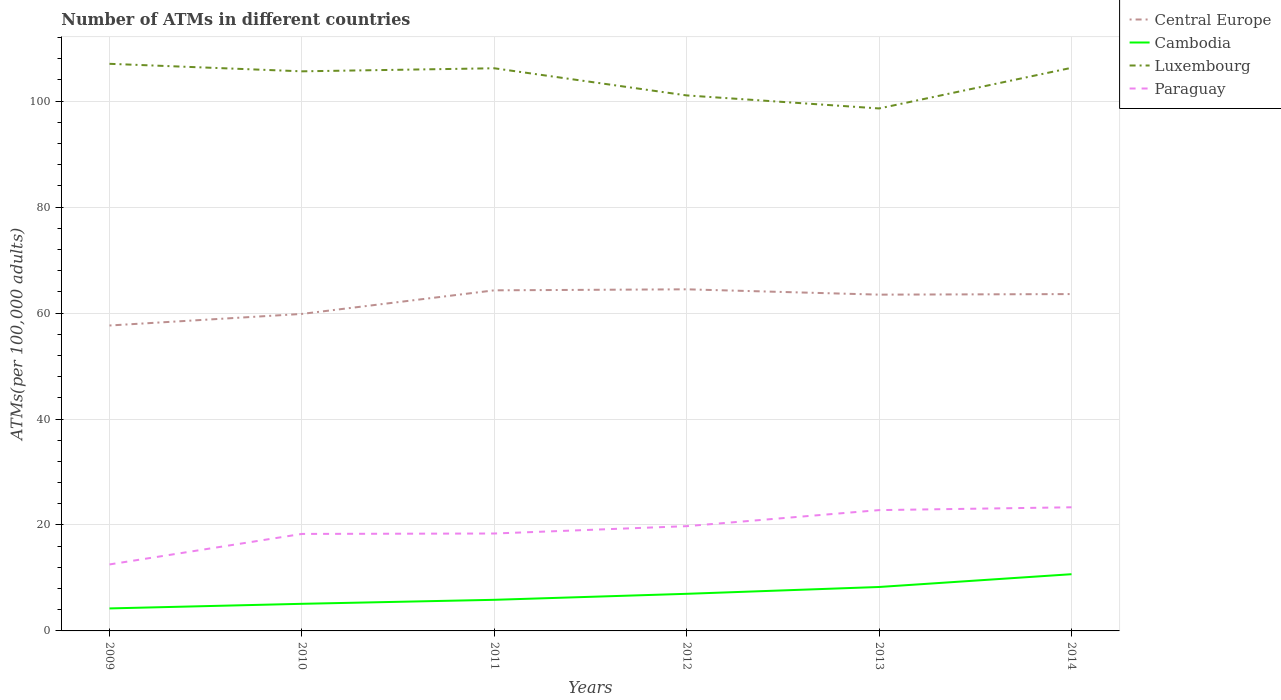Is the number of lines equal to the number of legend labels?
Provide a succinct answer. Yes. Across all years, what is the maximum number of ATMs in Luxembourg?
Your response must be concise. 98.62. What is the total number of ATMs in Luxembourg in the graph?
Ensure brevity in your answer.  -7.67. What is the difference between the highest and the second highest number of ATMs in Central Europe?
Ensure brevity in your answer.  6.83. What is the difference between the highest and the lowest number of ATMs in Central Europe?
Offer a terse response. 4. Is the number of ATMs in Cambodia strictly greater than the number of ATMs in Central Europe over the years?
Your response must be concise. Yes. How many years are there in the graph?
Provide a short and direct response. 6. Does the graph contain any zero values?
Offer a very short reply. No. Does the graph contain grids?
Provide a short and direct response. Yes. What is the title of the graph?
Your answer should be very brief. Number of ATMs in different countries. Does "Turkey" appear as one of the legend labels in the graph?
Keep it short and to the point. No. What is the label or title of the X-axis?
Your answer should be very brief. Years. What is the label or title of the Y-axis?
Provide a succinct answer. ATMs(per 100,0 adults). What is the ATMs(per 100,000 adults) in Central Europe in 2009?
Keep it short and to the point. 57.65. What is the ATMs(per 100,000 adults) in Cambodia in 2009?
Your answer should be compact. 4.25. What is the ATMs(per 100,000 adults) of Luxembourg in 2009?
Provide a succinct answer. 107.05. What is the ATMs(per 100,000 adults) in Paraguay in 2009?
Ensure brevity in your answer.  12.55. What is the ATMs(per 100,000 adults) of Central Europe in 2010?
Keep it short and to the point. 59.84. What is the ATMs(per 100,000 adults) in Cambodia in 2010?
Ensure brevity in your answer.  5.12. What is the ATMs(per 100,000 adults) of Luxembourg in 2010?
Offer a very short reply. 105.63. What is the ATMs(per 100,000 adults) in Paraguay in 2010?
Your answer should be very brief. 18.31. What is the ATMs(per 100,000 adults) of Central Europe in 2011?
Make the answer very short. 64.29. What is the ATMs(per 100,000 adults) in Cambodia in 2011?
Keep it short and to the point. 5.87. What is the ATMs(per 100,000 adults) of Luxembourg in 2011?
Give a very brief answer. 106.2. What is the ATMs(per 100,000 adults) in Paraguay in 2011?
Offer a very short reply. 18.39. What is the ATMs(per 100,000 adults) in Central Europe in 2012?
Provide a short and direct response. 64.48. What is the ATMs(per 100,000 adults) in Cambodia in 2012?
Ensure brevity in your answer.  7. What is the ATMs(per 100,000 adults) of Luxembourg in 2012?
Make the answer very short. 101.08. What is the ATMs(per 100,000 adults) of Paraguay in 2012?
Give a very brief answer. 19.78. What is the ATMs(per 100,000 adults) in Central Europe in 2013?
Provide a short and direct response. 63.48. What is the ATMs(per 100,000 adults) in Cambodia in 2013?
Offer a very short reply. 8.29. What is the ATMs(per 100,000 adults) of Luxembourg in 2013?
Give a very brief answer. 98.62. What is the ATMs(per 100,000 adults) in Paraguay in 2013?
Your answer should be very brief. 22.8. What is the ATMs(per 100,000 adults) of Central Europe in 2014?
Provide a short and direct response. 63.58. What is the ATMs(per 100,000 adults) in Cambodia in 2014?
Offer a very short reply. 10.71. What is the ATMs(per 100,000 adults) of Luxembourg in 2014?
Your answer should be compact. 106.29. What is the ATMs(per 100,000 adults) in Paraguay in 2014?
Offer a terse response. 23.34. Across all years, what is the maximum ATMs(per 100,000 adults) in Central Europe?
Your answer should be compact. 64.48. Across all years, what is the maximum ATMs(per 100,000 adults) of Cambodia?
Give a very brief answer. 10.71. Across all years, what is the maximum ATMs(per 100,000 adults) of Luxembourg?
Give a very brief answer. 107.05. Across all years, what is the maximum ATMs(per 100,000 adults) in Paraguay?
Make the answer very short. 23.34. Across all years, what is the minimum ATMs(per 100,000 adults) of Central Europe?
Give a very brief answer. 57.65. Across all years, what is the minimum ATMs(per 100,000 adults) in Cambodia?
Your answer should be very brief. 4.25. Across all years, what is the minimum ATMs(per 100,000 adults) in Luxembourg?
Give a very brief answer. 98.62. Across all years, what is the minimum ATMs(per 100,000 adults) of Paraguay?
Provide a short and direct response. 12.55. What is the total ATMs(per 100,000 adults) of Central Europe in the graph?
Your response must be concise. 373.31. What is the total ATMs(per 100,000 adults) of Cambodia in the graph?
Your answer should be very brief. 41.24. What is the total ATMs(per 100,000 adults) in Luxembourg in the graph?
Provide a short and direct response. 624.87. What is the total ATMs(per 100,000 adults) of Paraguay in the graph?
Provide a short and direct response. 115.16. What is the difference between the ATMs(per 100,000 adults) of Central Europe in 2009 and that in 2010?
Keep it short and to the point. -2.19. What is the difference between the ATMs(per 100,000 adults) in Cambodia in 2009 and that in 2010?
Make the answer very short. -0.87. What is the difference between the ATMs(per 100,000 adults) in Luxembourg in 2009 and that in 2010?
Give a very brief answer. 1.42. What is the difference between the ATMs(per 100,000 adults) in Paraguay in 2009 and that in 2010?
Your answer should be compact. -5.76. What is the difference between the ATMs(per 100,000 adults) of Central Europe in 2009 and that in 2011?
Offer a terse response. -6.64. What is the difference between the ATMs(per 100,000 adults) in Cambodia in 2009 and that in 2011?
Provide a succinct answer. -1.62. What is the difference between the ATMs(per 100,000 adults) of Luxembourg in 2009 and that in 2011?
Offer a terse response. 0.84. What is the difference between the ATMs(per 100,000 adults) of Paraguay in 2009 and that in 2011?
Ensure brevity in your answer.  -5.84. What is the difference between the ATMs(per 100,000 adults) of Central Europe in 2009 and that in 2012?
Make the answer very short. -6.83. What is the difference between the ATMs(per 100,000 adults) in Cambodia in 2009 and that in 2012?
Your response must be concise. -2.76. What is the difference between the ATMs(per 100,000 adults) in Luxembourg in 2009 and that in 2012?
Your response must be concise. 5.97. What is the difference between the ATMs(per 100,000 adults) of Paraguay in 2009 and that in 2012?
Give a very brief answer. -7.23. What is the difference between the ATMs(per 100,000 adults) in Central Europe in 2009 and that in 2013?
Provide a short and direct response. -5.82. What is the difference between the ATMs(per 100,000 adults) of Cambodia in 2009 and that in 2013?
Your answer should be compact. -4.04. What is the difference between the ATMs(per 100,000 adults) in Luxembourg in 2009 and that in 2013?
Offer a terse response. 8.43. What is the difference between the ATMs(per 100,000 adults) of Paraguay in 2009 and that in 2013?
Ensure brevity in your answer.  -10.26. What is the difference between the ATMs(per 100,000 adults) of Central Europe in 2009 and that in 2014?
Your answer should be very brief. -5.93. What is the difference between the ATMs(per 100,000 adults) of Cambodia in 2009 and that in 2014?
Your response must be concise. -6.46. What is the difference between the ATMs(per 100,000 adults) of Luxembourg in 2009 and that in 2014?
Make the answer very short. 0.76. What is the difference between the ATMs(per 100,000 adults) of Paraguay in 2009 and that in 2014?
Keep it short and to the point. -10.79. What is the difference between the ATMs(per 100,000 adults) in Central Europe in 2010 and that in 2011?
Keep it short and to the point. -4.45. What is the difference between the ATMs(per 100,000 adults) of Cambodia in 2010 and that in 2011?
Your answer should be very brief. -0.76. What is the difference between the ATMs(per 100,000 adults) in Luxembourg in 2010 and that in 2011?
Ensure brevity in your answer.  -0.58. What is the difference between the ATMs(per 100,000 adults) of Paraguay in 2010 and that in 2011?
Offer a very short reply. -0.08. What is the difference between the ATMs(per 100,000 adults) in Central Europe in 2010 and that in 2012?
Keep it short and to the point. -4.64. What is the difference between the ATMs(per 100,000 adults) of Cambodia in 2010 and that in 2012?
Make the answer very short. -1.89. What is the difference between the ATMs(per 100,000 adults) in Luxembourg in 2010 and that in 2012?
Your answer should be very brief. 4.55. What is the difference between the ATMs(per 100,000 adults) in Paraguay in 2010 and that in 2012?
Your answer should be very brief. -1.47. What is the difference between the ATMs(per 100,000 adults) of Central Europe in 2010 and that in 2013?
Provide a short and direct response. -3.64. What is the difference between the ATMs(per 100,000 adults) of Cambodia in 2010 and that in 2013?
Your answer should be very brief. -3.18. What is the difference between the ATMs(per 100,000 adults) in Luxembourg in 2010 and that in 2013?
Keep it short and to the point. 7.01. What is the difference between the ATMs(per 100,000 adults) in Paraguay in 2010 and that in 2013?
Provide a succinct answer. -4.5. What is the difference between the ATMs(per 100,000 adults) of Central Europe in 2010 and that in 2014?
Offer a very short reply. -3.74. What is the difference between the ATMs(per 100,000 adults) in Cambodia in 2010 and that in 2014?
Provide a short and direct response. -5.59. What is the difference between the ATMs(per 100,000 adults) in Luxembourg in 2010 and that in 2014?
Make the answer very short. -0.66. What is the difference between the ATMs(per 100,000 adults) in Paraguay in 2010 and that in 2014?
Ensure brevity in your answer.  -5.03. What is the difference between the ATMs(per 100,000 adults) in Central Europe in 2011 and that in 2012?
Provide a succinct answer. -0.19. What is the difference between the ATMs(per 100,000 adults) in Cambodia in 2011 and that in 2012?
Ensure brevity in your answer.  -1.13. What is the difference between the ATMs(per 100,000 adults) of Luxembourg in 2011 and that in 2012?
Provide a succinct answer. 5.12. What is the difference between the ATMs(per 100,000 adults) in Paraguay in 2011 and that in 2012?
Provide a short and direct response. -1.39. What is the difference between the ATMs(per 100,000 adults) of Central Europe in 2011 and that in 2013?
Offer a terse response. 0.81. What is the difference between the ATMs(per 100,000 adults) of Cambodia in 2011 and that in 2013?
Your response must be concise. -2.42. What is the difference between the ATMs(per 100,000 adults) in Luxembourg in 2011 and that in 2013?
Offer a very short reply. 7.58. What is the difference between the ATMs(per 100,000 adults) in Paraguay in 2011 and that in 2013?
Offer a very short reply. -4.42. What is the difference between the ATMs(per 100,000 adults) in Central Europe in 2011 and that in 2014?
Provide a succinct answer. 0.71. What is the difference between the ATMs(per 100,000 adults) in Cambodia in 2011 and that in 2014?
Provide a succinct answer. -4.83. What is the difference between the ATMs(per 100,000 adults) of Luxembourg in 2011 and that in 2014?
Your answer should be compact. -0.09. What is the difference between the ATMs(per 100,000 adults) of Paraguay in 2011 and that in 2014?
Provide a succinct answer. -4.95. What is the difference between the ATMs(per 100,000 adults) of Central Europe in 2012 and that in 2013?
Provide a short and direct response. 1.01. What is the difference between the ATMs(per 100,000 adults) in Cambodia in 2012 and that in 2013?
Ensure brevity in your answer.  -1.29. What is the difference between the ATMs(per 100,000 adults) in Luxembourg in 2012 and that in 2013?
Your answer should be very brief. 2.46. What is the difference between the ATMs(per 100,000 adults) in Paraguay in 2012 and that in 2013?
Ensure brevity in your answer.  -3.03. What is the difference between the ATMs(per 100,000 adults) in Central Europe in 2012 and that in 2014?
Give a very brief answer. 0.9. What is the difference between the ATMs(per 100,000 adults) of Cambodia in 2012 and that in 2014?
Your answer should be very brief. -3.7. What is the difference between the ATMs(per 100,000 adults) of Luxembourg in 2012 and that in 2014?
Give a very brief answer. -5.21. What is the difference between the ATMs(per 100,000 adults) in Paraguay in 2012 and that in 2014?
Provide a short and direct response. -3.56. What is the difference between the ATMs(per 100,000 adults) of Central Europe in 2013 and that in 2014?
Offer a very short reply. -0.11. What is the difference between the ATMs(per 100,000 adults) of Cambodia in 2013 and that in 2014?
Ensure brevity in your answer.  -2.41. What is the difference between the ATMs(per 100,000 adults) in Luxembourg in 2013 and that in 2014?
Give a very brief answer. -7.67. What is the difference between the ATMs(per 100,000 adults) in Paraguay in 2013 and that in 2014?
Provide a short and direct response. -0.53. What is the difference between the ATMs(per 100,000 adults) in Central Europe in 2009 and the ATMs(per 100,000 adults) in Cambodia in 2010?
Provide a short and direct response. 52.53. What is the difference between the ATMs(per 100,000 adults) of Central Europe in 2009 and the ATMs(per 100,000 adults) of Luxembourg in 2010?
Give a very brief answer. -47.98. What is the difference between the ATMs(per 100,000 adults) in Central Europe in 2009 and the ATMs(per 100,000 adults) in Paraguay in 2010?
Your answer should be compact. 39.34. What is the difference between the ATMs(per 100,000 adults) of Cambodia in 2009 and the ATMs(per 100,000 adults) of Luxembourg in 2010?
Ensure brevity in your answer.  -101.38. What is the difference between the ATMs(per 100,000 adults) of Cambodia in 2009 and the ATMs(per 100,000 adults) of Paraguay in 2010?
Give a very brief answer. -14.06. What is the difference between the ATMs(per 100,000 adults) of Luxembourg in 2009 and the ATMs(per 100,000 adults) of Paraguay in 2010?
Make the answer very short. 88.74. What is the difference between the ATMs(per 100,000 adults) of Central Europe in 2009 and the ATMs(per 100,000 adults) of Cambodia in 2011?
Your answer should be compact. 51.78. What is the difference between the ATMs(per 100,000 adults) in Central Europe in 2009 and the ATMs(per 100,000 adults) in Luxembourg in 2011?
Offer a terse response. -48.55. What is the difference between the ATMs(per 100,000 adults) in Central Europe in 2009 and the ATMs(per 100,000 adults) in Paraguay in 2011?
Keep it short and to the point. 39.26. What is the difference between the ATMs(per 100,000 adults) in Cambodia in 2009 and the ATMs(per 100,000 adults) in Luxembourg in 2011?
Provide a short and direct response. -101.96. What is the difference between the ATMs(per 100,000 adults) of Cambodia in 2009 and the ATMs(per 100,000 adults) of Paraguay in 2011?
Make the answer very short. -14.14. What is the difference between the ATMs(per 100,000 adults) of Luxembourg in 2009 and the ATMs(per 100,000 adults) of Paraguay in 2011?
Your response must be concise. 88.66. What is the difference between the ATMs(per 100,000 adults) in Central Europe in 2009 and the ATMs(per 100,000 adults) in Cambodia in 2012?
Offer a terse response. 50.65. What is the difference between the ATMs(per 100,000 adults) of Central Europe in 2009 and the ATMs(per 100,000 adults) of Luxembourg in 2012?
Your answer should be very brief. -43.43. What is the difference between the ATMs(per 100,000 adults) in Central Europe in 2009 and the ATMs(per 100,000 adults) in Paraguay in 2012?
Ensure brevity in your answer.  37.88. What is the difference between the ATMs(per 100,000 adults) in Cambodia in 2009 and the ATMs(per 100,000 adults) in Luxembourg in 2012?
Ensure brevity in your answer.  -96.83. What is the difference between the ATMs(per 100,000 adults) in Cambodia in 2009 and the ATMs(per 100,000 adults) in Paraguay in 2012?
Offer a very short reply. -15.53. What is the difference between the ATMs(per 100,000 adults) of Luxembourg in 2009 and the ATMs(per 100,000 adults) of Paraguay in 2012?
Your answer should be compact. 87.27. What is the difference between the ATMs(per 100,000 adults) of Central Europe in 2009 and the ATMs(per 100,000 adults) of Cambodia in 2013?
Your answer should be compact. 49.36. What is the difference between the ATMs(per 100,000 adults) in Central Europe in 2009 and the ATMs(per 100,000 adults) in Luxembourg in 2013?
Offer a very short reply. -40.97. What is the difference between the ATMs(per 100,000 adults) of Central Europe in 2009 and the ATMs(per 100,000 adults) of Paraguay in 2013?
Make the answer very short. 34.85. What is the difference between the ATMs(per 100,000 adults) of Cambodia in 2009 and the ATMs(per 100,000 adults) of Luxembourg in 2013?
Your response must be concise. -94.37. What is the difference between the ATMs(per 100,000 adults) of Cambodia in 2009 and the ATMs(per 100,000 adults) of Paraguay in 2013?
Provide a short and direct response. -18.56. What is the difference between the ATMs(per 100,000 adults) of Luxembourg in 2009 and the ATMs(per 100,000 adults) of Paraguay in 2013?
Your answer should be compact. 84.24. What is the difference between the ATMs(per 100,000 adults) of Central Europe in 2009 and the ATMs(per 100,000 adults) of Cambodia in 2014?
Make the answer very short. 46.94. What is the difference between the ATMs(per 100,000 adults) of Central Europe in 2009 and the ATMs(per 100,000 adults) of Luxembourg in 2014?
Provide a succinct answer. -48.64. What is the difference between the ATMs(per 100,000 adults) of Central Europe in 2009 and the ATMs(per 100,000 adults) of Paraguay in 2014?
Give a very brief answer. 34.31. What is the difference between the ATMs(per 100,000 adults) of Cambodia in 2009 and the ATMs(per 100,000 adults) of Luxembourg in 2014?
Your response must be concise. -102.04. What is the difference between the ATMs(per 100,000 adults) of Cambodia in 2009 and the ATMs(per 100,000 adults) of Paraguay in 2014?
Provide a succinct answer. -19.09. What is the difference between the ATMs(per 100,000 adults) of Luxembourg in 2009 and the ATMs(per 100,000 adults) of Paraguay in 2014?
Provide a short and direct response. 83.71. What is the difference between the ATMs(per 100,000 adults) in Central Europe in 2010 and the ATMs(per 100,000 adults) in Cambodia in 2011?
Give a very brief answer. 53.96. What is the difference between the ATMs(per 100,000 adults) in Central Europe in 2010 and the ATMs(per 100,000 adults) in Luxembourg in 2011?
Your answer should be compact. -46.37. What is the difference between the ATMs(per 100,000 adults) in Central Europe in 2010 and the ATMs(per 100,000 adults) in Paraguay in 2011?
Make the answer very short. 41.45. What is the difference between the ATMs(per 100,000 adults) of Cambodia in 2010 and the ATMs(per 100,000 adults) of Luxembourg in 2011?
Your response must be concise. -101.09. What is the difference between the ATMs(per 100,000 adults) of Cambodia in 2010 and the ATMs(per 100,000 adults) of Paraguay in 2011?
Offer a very short reply. -13.27. What is the difference between the ATMs(per 100,000 adults) in Luxembourg in 2010 and the ATMs(per 100,000 adults) in Paraguay in 2011?
Make the answer very short. 87.24. What is the difference between the ATMs(per 100,000 adults) of Central Europe in 2010 and the ATMs(per 100,000 adults) of Cambodia in 2012?
Offer a terse response. 52.83. What is the difference between the ATMs(per 100,000 adults) of Central Europe in 2010 and the ATMs(per 100,000 adults) of Luxembourg in 2012?
Your answer should be compact. -41.24. What is the difference between the ATMs(per 100,000 adults) of Central Europe in 2010 and the ATMs(per 100,000 adults) of Paraguay in 2012?
Give a very brief answer. 40.06. What is the difference between the ATMs(per 100,000 adults) in Cambodia in 2010 and the ATMs(per 100,000 adults) in Luxembourg in 2012?
Offer a very short reply. -95.96. What is the difference between the ATMs(per 100,000 adults) of Cambodia in 2010 and the ATMs(per 100,000 adults) of Paraguay in 2012?
Keep it short and to the point. -14.66. What is the difference between the ATMs(per 100,000 adults) in Luxembourg in 2010 and the ATMs(per 100,000 adults) in Paraguay in 2012?
Offer a terse response. 85.85. What is the difference between the ATMs(per 100,000 adults) of Central Europe in 2010 and the ATMs(per 100,000 adults) of Cambodia in 2013?
Keep it short and to the point. 51.54. What is the difference between the ATMs(per 100,000 adults) in Central Europe in 2010 and the ATMs(per 100,000 adults) in Luxembourg in 2013?
Ensure brevity in your answer.  -38.78. What is the difference between the ATMs(per 100,000 adults) of Central Europe in 2010 and the ATMs(per 100,000 adults) of Paraguay in 2013?
Your answer should be very brief. 37.03. What is the difference between the ATMs(per 100,000 adults) of Cambodia in 2010 and the ATMs(per 100,000 adults) of Luxembourg in 2013?
Offer a terse response. -93.5. What is the difference between the ATMs(per 100,000 adults) of Cambodia in 2010 and the ATMs(per 100,000 adults) of Paraguay in 2013?
Keep it short and to the point. -17.69. What is the difference between the ATMs(per 100,000 adults) in Luxembourg in 2010 and the ATMs(per 100,000 adults) in Paraguay in 2013?
Provide a succinct answer. 82.82. What is the difference between the ATMs(per 100,000 adults) of Central Europe in 2010 and the ATMs(per 100,000 adults) of Cambodia in 2014?
Your response must be concise. 49.13. What is the difference between the ATMs(per 100,000 adults) of Central Europe in 2010 and the ATMs(per 100,000 adults) of Luxembourg in 2014?
Give a very brief answer. -46.45. What is the difference between the ATMs(per 100,000 adults) in Central Europe in 2010 and the ATMs(per 100,000 adults) in Paraguay in 2014?
Keep it short and to the point. 36.5. What is the difference between the ATMs(per 100,000 adults) in Cambodia in 2010 and the ATMs(per 100,000 adults) in Luxembourg in 2014?
Provide a short and direct response. -101.17. What is the difference between the ATMs(per 100,000 adults) in Cambodia in 2010 and the ATMs(per 100,000 adults) in Paraguay in 2014?
Keep it short and to the point. -18.22. What is the difference between the ATMs(per 100,000 adults) of Luxembourg in 2010 and the ATMs(per 100,000 adults) of Paraguay in 2014?
Your answer should be compact. 82.29. What is the difference between the ATMs(per 100,000 adults) in Central Europe in 2011 and the ATMs(per 100,000 adults) in Cambodia in 2012?
Make the answer very short. 57.28. What is the difference between the ATMs(per 100,000 adults) in Central Europe in 2011 and the ATMs(per 100,000 adults) in Luxembourg in 2012?
Provide a succinct answer. -36.79. What is the difference between the ATMs(per 100,000 adults) in Central Europe in 2011 and the ATMs(per 100,000 adults) in Paraguay in 2012?
Your answer should be very brief. 44.51. What is the difference between the ATMs(per 100,000 adults) of Cambodia in 2011 and the ATMs(per 100,000 adults) of Luxembourg in 2012?
Your response must be concise. -95.21. What is the difference between the ATMs(per 100,000 adults) in Cambodia in 2011 and the ATMs(per 100,000 adults) in Paraguay in 2012?
Ensure brevity in your answer.  -13.9. What is the difference between the ATMs(per 100,000 adults) in Luxembourg in 2011 and the ATMs(per 100,000 adults) in Paraguay in 2012?
Keep it short and to the point. 86.43. What is the difference between the ATMs(per 100,000 adults) in Central Europe in 2011 and the ATMs(per 100,000 adults) in Cambodia in 2013?
Provide a succinct answer. 56. What is the difference between the ATMs(per 100,000 adults) in Central Europe in 2011 and the ATMs(per 100,000 adults) in Luxembourg in 2013?
Make the answer very short. -34.33. What is the difference between the ATMs(per 100,000 adults) in Central Europe in 2011 and the ATMs(per 100,000 adults) in Paraguay in 2013?
Your answer should be compact. 41.48. What is the difference between the ATMs(per 100,000 adults) of Cambodia in 2011 and the ATMs(per 100,000 adults) of Luxembourg in 2013?
Your response must be concise. -92.75. What is the difference between the ATMs(per 100,000 adults) of Cambodia in 2011 and the ATMs(per 100,000 adults) of Paraguay in 2013?
Provide a short and direct response. -16.93. What is the difference between the ATMs(per 100,000 adults) of Luxembourg in 2011 and the ATMs(per 100,000 adults) of Paraguay in 2013?
Your answer should be compact. 83.4. What is the difference between the ATMs(per 100,000 adults) of Central Europe in 2011 and the ATMs(per 100,000 adults) of Cambodia in 2014?
Make the answer very short. 53.58. What is the difference between the ATMs(per 100,000 adults) of Central Europe in 2011 and the ATMs(per 100,000 adults) of Luxembourg in 2014?
Offer a terse response. -42. What is the difference between the ATMs(per 100,000 adults) of Central Europe in 2011 and the ATMs(per 100,000 adults) of Paraguay in 2014?
Keep it short and to the point. 40.95. What is the difference between the ATMs(per 100,000 adults) of Cambodia in 2011 and the ATMs(per 100,000 adults) of Luxembourg in 2014?
Provide a succinct answer. -100.42. What is the difference between the ATMs(per 100,000 adults) of Cambodia in 2011 and the ATMs(per 100,000 adults) of Paraguay in 2014?
Your answer should be very brief. -17.46. What is the difference between the ATMs(per 100,000 adults) of Luxembourg in 2011 and the ATMs(per 100,000 adults) of Paraguay in 2014?
Provide a succinct answer. 82.87. What is the difference between the ATMs(per 100,000 adults) of Central Europe in 2012 and the ATMs(per 100,000 adults) of Cambodia in 2013?
Your answer should be very brief. 56.19. What is the difference between the ATMs(per 100,000 adults) of Central Europe in 2012 and the ATMs(per 100,000 adults) of Luxembourg in 2013?
Your answer should be compact. -34.14. What is the difference between the ATMs(per 100,000 adults) in Central Europe in 2012 and the ATMs(per 100,000 adults) in Paraguay in 2013?
Your answer should be very brief. 41.68. What is the difference between the ATMs(per 100,000 adults) of Cambodia in 2012 and the ATMs(per 100,000 adults) of Luxembourg in 2013?
Ensure brevity in your answer.  -91.61. What is the difference between the ATMs(per 100,000 adults) of Cambodia in 2012 and the ATMs(per 100,000 adults) of Paraguay in 2013?
Offer a very short reply. -15.8. What is the difference between the ATMs(per 100,000 adults) in Luxembourg in 2012 and the ATMs(per 100,000 adults) in Paraguay in 2013?
Provide a succinct answer. 78.28. What is the difference between the ATMs(per 100,000 adults) in Central Europe in 2012 and the ATMs(per 100,000 adults) in Cambodia in 2014?
Offer a very short reply. 53.77. What is the difference between the ATMs(per 100,000 adults) in Central Europe in 2012 and the ATMs(per 100,000 adults) in Luxembourg in 2014?
Offer a very short reply. -41.81. What is the difference between the ATMs(per 100,000 adults) of Central Europe in 2012 and the ATMs(per 100,000 adults) of Paraguay in 2014?
Your answer should be compact. 41.14. What is the difference between the ATMs(per 100,000 adults) of Cambodia in 2012 and the ATMs(per 100,000 adults) of Luxembourg in 2014?
Provide a short and direct response. -99.29. What is the difference between the ATMs(per 100,000 adults) of Cambodia in 2012 and the ATMs(per 100,000 adults) of Paraguay in 2014?
Your answer should be compact. -16.33. What is the difference between the ATMs(per 100,000 adults) in Luxembourg in 2012 and the ATMs(per 100,000 adults) in Paraguay in 2014?
Your response must be concise. 77.74. What is the difference between the ATMs(per 100,000 adults) of Central Europe in 2013 and the ATMs(per 100,000 adults) of Cambodia in 2014?
Provide a succinct answer. 52.77. What is the difference between the ATMs(per 100,000 adults) of Central Europe in 2013 and the ATMs(per 100,000 adults) of Luxembourg in 2014?
Offer a very short reply. -42.82. What is the difference between the ATMs(per 100,000 adults) of Central Europe in 2013 and the ATMs(per 100,000 adults) of Paraguay in 2014?
Offer a terse response. 40.14. What is the difference between the ATMs(per 100,000 adults) of Cambodia in 2013 and the ATMs(per 100,000 adults) of Luxembourg in 2014?
Provide a short and direct response. -98. What is the difference between the ATMs(per 100,000 adults) of Cambodia in 2013 and the ATMs(per 100,000 adults) of Paraguay in 2014?
Give a very brief answer. -15.04. What is the difference between the ATMs(per 100,000 adults) in Luxembourg in 2013 and the ATMs(per 100,000 adults) in Paraguay in 2014?
Make the answer very short. 75.28. What is the average ATMs(per 100,000 adults) of Central Europe per year?
Keep it short and to the point. 62.22. What is the average ATMs(per 100,000 adults) in Cambodia per year?
Provide a short and direct response. 6.87. What is the average ATMs(per 100,000 adults) of Luxembourg per year?
Your answer should be very brief. 104.14. What is the average ATMs(per 100,000 adults) of Paraguay per year?
Make the answer very short. 19.19. In the year 2009, what is the difference between the ATMs(per 100,000 adults) in Central Europe and ATMs(per 100,000 adults) in Cambodia?
Ensure brevity in your answer.  53.4. In the year 2009, what is the difference between the ATMs(per 100,000 adults) in Central Europe and ATMs(per 100,000 adults) in Luxembourg?
Make the answer very short. -49.4. In the year 2009, what is the difference between the ATMs(per 100,000 adults) in Central Europe and ATMs(per 100,000 adults) in Paraguay?
Give a very brief answer. 45.1. In the year 2009, what is the difference between the ATMs(per 100,000 adults) of Cambodia and ATMs(per 100,000 adults) of Luxembourg?
Provide a succinct answer. -102.8. In the year 2009, what is the difference between the ATMs(per 100,000 adults) in Cambodia and ATMs(per 100,000 adults) in Paraguay?
Keep it short and to the point. -8.3. In the year 2009, what is the difference between the ATMs(per 100,000 adults) in Luxembourg and ATMs(per 100,000 adults) in Paraguay?
Provide a succinct answer. 94.5. In the year 2010, what is the difference between the ATMs(per 100,000 adults) of Central Europe and ATMs(per 100,000 adults) of Cambodia?
Your answer should be compact. 54.72. In the year 2010, what is the difference between the ATMs(per 100,000 adults) in Central Europe and ATMs(per 100,000 adults) in Luxembourg?
Your answer should be compact. -45.79. In the year 2010, what is the difference between the ATMs(per 100,000 adults) of Central Europe and ATMs(per 100,000 adults) of Paraguay?
Provide a succinct answer. 41.53. In the year 2010, what is the difference between the ATMs(per 100,000 adults) in Cambodia and ATMs(per 100,000 adults) in Luxembourg?
Provide a short and direct response. -100.51. In the year 2010, what is the difference between the ATMs(per 100,000 adults) in Cambodia and ATMs(per 100,000 adults) in Paraguay?
Offer a terse response. -13.19. In the year 2010, what is the difference between the ATMs(per 100,000 adults) of Luxembourg and ATMs(per 100,000 adults) of Paraguay?
Keep it short and to the point. 87.32. In the year 2011, what is the difference between the ATMs(per 100,000 adults) of Central Europe and ATMs(per 100,000 adults) of Cambodia?
Your answer should be compact. 58.42. In the year 2011, what is the difference between the ATMs(per 100,000 adults) in Central Europe and ATMs(per 100,000 adults) in Luxembourg?
Your response must be concise. -41.92. In the year 2011, what is the difference between the ATMs(per 100,000 adults) of Central Europe and ATMs(per 100,000 adults) of Paraguay?
Your answer should be very brief. 45.9. In the year 2011, what is the difference between the ATMs(per 100,000 adults) of Cambodia and ATMs(per 100,000 adults) of Luxembourg?
Your response must be concise. -100.33. In the year 2011, what is the difference between the ATMs(per 100,000 adults) of Cambodia and ATMs(per 100,000 adults) of Paraguay?
Provide a short and direct response. -12.51. In the year 2011, what is the difference between the ATMs(per 100,000 adults) of Luxembourg and ATMs(per 100,000 adults) of Paraguay?
Your answer should be compact. 87.82. In the year 2012, what is the difference between the ATMs(per 100,000 adults) in Central Europe and ATMs(per 100,000 adults) in Cambodia?
Make the answer very short. 57.48. In the year 2012, what is the difference between the ATMs(per 100,000 adults) in Central Europe and ATMs(per 100,000 adults) in Luxembourg?
Your response must be concise. -36.6. In the year 2012, what is the difference between the ATMs(per 100,000 adults) in Central Europe and ATMs(per 100,000 adults) in Paraguay?
Your response must be concise. 44.71. In the year 2012, what is the difference between the ATMs(per 100,000 adults) in Cambodia and ATMs(per 100,000 adults) in Luxembourg?
Your answer should be compact. -94.08. In the year 2012, what is the difference between the ATMs(per 100,000 adults) in Cambodia and ATMs(per 100,000 adults) in Paraguay?
Provide a short and direct response. -12.77. In the year 2012, what is the difference between the ATMs(per 100,000 adults) of Luxembourg and ATMs(per 100,000 adults) of Paraguay?
Offer a terse response. 81.3. In the year 2013, what is the difference between the ATMs(per 100,000 adults) of Central Europe and ATMs(per 100,000 adults) of Cambodia?
Provide a short and direct response. 55.18. In the year 2013, what is the difference between the ATMs(per 100,000 adults) of Central Europe and ATMs(per 100,000 adults) of Luxembourg?
Ensure brevity in your answer.  -35.14. In the year 2013, what is the difference between the ATMs(per 100,000 adults) in Central Europe and ATMs(per 100,000 adults) in Paraguay?
Your answer should be compact. 40.67. In the year 2013, what is the difference between the ATMs(per 100,000 adults) in Cambodia and ATMs(per 100,000 adults) in Luxembourg?
Your answer should be very brief. -90.33. In the year 2013, what is the difference between the ATMs(per 100,000 adults) in Cambodia and ATMs(per 100,000 adults) in Paraguay?
Your answer should be compact. -14.51. In the year 2013, what is the difference between the ATMs(per 100,000 adults) in Luxembourg and ATMs(per 100,000 adults) in Paraguay?
Your response must be concise. 75.82. In the year 2014, what is the difference between the ATMs(per 100,000 adults) of Central Europe and ATMs(per 100,000 adults) of Cambodia?
Your answer should be compact. 52.87. In the year 2014, what is the difference between the ATMs(per 100,000 adults) of Central Europe and ATMs(per 100,000 adults) of Luxembourg?
Your response must be concise. -42.71. In the year 2014, what is the difference between the ATMs(per 100,000 adults) of Central Europe and ATMs(per 100,000 adults) of Paraguay?
Your answer should be compact. 40.24. In the year 2014, what is the difference between the ATMs(per 100,000 adults) in Cambodia and ATMs(per 100,000 adults) in Luxembourg?
Give a very brief answer. -95.58. In the year 2014, what is the difference between the ATMs(per 100,000 adults) of Cambodia and ATMs(per 100,000 adults) of Paraguay?
Offer a terse response. -12.63. In the year 2014, what is the difference between the ATMs(per 100,000 adults) in Luxembourg and ATMs(per 100,000 adults) in Paraguay?
Your response must be concise. 82.95. What is the ratio of the ATMs(per 100,000 adults) in Central Europe in 2009 to that in 2010?
Your answer should be compact. 0.96. What is the ratio of the ATMs(per 100,000 adults) of Cambodia in 2009 to that in 2010?
Ensure brevity in your answer.  0.83. What is the ratio of the ATMs(per 100,000 adults) of Luxembourg in 2009 to that in 2010?
Your response must be concise. 1.01. What is the ratio of the ATMs(per 100,000 adults) of Paraguay in 2009 to that in 2010?
Offer a very short reply. 0.69. What is the ratio of the ATMs(per 100,000 adults) of Central Europe in 2009 to that in 2011?
Make the answer very short. 0.9. What is the ratio of the ATMs(per 100,000 adults) of Cambodia in 2009 to that in 2011?
Your answer should be compact. 0.72. What is the ratio of the ATMs(per 100,000 adults) of Luxembourg in 2009 to that in 2011?
Offer a terse response. 1.01. What is the ratio of the ATMs(per 100,000 adults) of Paraguay in 2009 to that in 2011?
Provide a succinct answer. 0.68. What is the ratio of the ATMs(per 100,000 adults) of Central Europe in 2009 to that in 2012?
Make the answer very short. 0.89. What is the ratio of the ATMs(per 100,000 adults) in Cambodia in 2009 to that in 2012?
Give a very brief answer. 0.61. What is the ratio of the ATMs(per 100,000 adults) of Luxembourg in 2009 to that in 2012?
Give a very brief answer. 1.06. What is the ratio of the ATMs(per 100,000 adults) in Paraguay in 2009 to that in 2012?
Offer a terse response. 0.63. What is the ratio of the ATMs(per 100,000 adults) of Central Europe in 2009 to that in 2013?
Your answer should be very brief. 0.91. What is the ratio of the ATMs(per 100,000 adults) of Cambodia in 2009 to that in 2013?
Offer a terse response. 0.51. What is the ratio of the ATMs(per 100,000 adults) in Luxembourg in 2009 to that in 2013?
Offer a very short reply. 1.09. What is the ratio of the ATMs(per 100,000 adults) in Paraguay in 2009 to that in 2013?
Make the answer very short. 0.55. What is the ratio of the ATMs(per 100,000 adults) of Central Europe in 2009 to that in 2014?
Your answer should be very brief. 0.91. What is the ratio of the ATMs(per 100,000 adults) of Cambodia in 2009 to that in 2014?
Provide a short and direct response. 0.4. What is the ratio of the ATMs(per 100,000 adults) in Luxembourg in 2009 to that in 2014?
Make the answer very short. 1.01. What is the ratio of the ATMs(per 100,000 adults) in Paraguay in 2009 to that in 2014?
Make the answer very short. 0.54. What is the ratio of the ATMs(per 100,000 adults) in Central Europe in 2010 to that in 2011?
Make the answer very short. 0.93. What is the ratio of the ATMs(per 100,000 adults) of Cambodia in 2010 to that in 2011?
Provide a succinct answer. 0.87. What is the ratio of the ATMs(per 100,000 adults) of Luxembourg in 2010 to that in 2011?
Provide a short and direct response. 0.99. What is the ratio of the ATMs(per 100,000 adults) in Paraguay in 2010 to that in 2011?
Your answer should be compact. 1. What is the ratio of the ATMs(per 100,000 adults) in Central Europe in 2010 to that in 2012?
Make the answer very short. 0.93. What is the ratio of the ATMs(per 100,000 adults) of Cambodia in 2010 to that in 2012?
Provide a succinct answer. 0.73. What is the ratio of the ATMs(per 100,000 adults) in Luxembourg in 2010 to that in 2012?
Provide a succinct answer. 1.04. What is the ratio of the ATMs(per 100,000 adults) in Paraguay in 2010 to that in 2012?
Provide a succinct answer. 0.93. What is the ratio of the ATMs(per 100,000 adults) in Central Europe in 2010 to that in 2013?
Your answer should be compact. 0.94. What is the ratio of the ATMs(per 100,000 adults) of Cambodia in 2010 to that in 2013?
Offer a terse response. 0.62. What is the ratio of the ATMs(per 100,000 adults) in Luxembourg in 2010 to that in 2013?
Provide a succinct answer. 1.07. What is the ratio of the ATMs(per 100,000 adults) of Paraguay in 2010 to that in 2013?
Give a very brief answer. 0.8. What is the ratio of the ATMs(per 100,000 adults) in Central Europe in 2010 to that in 2014?
Give a very brief answer. 0.94. What is the ratio of the ATMs(per 100,000 adults) in Cambodia in 2010 to that in 2014?
Your answer should be very brief. 0.48. What is the ratio of the ATMs(per 100,000 adults) of Luxembourg in 2010 to that in 2014?
Give a very brief answer. 0.99. What is the ratio of the ATMs(per 100,000 adults) of Paraguay in 2010 to that in 2014?
Your answer should be compact. 0.78. What is the ratio of the ATMs(per 100,000 adults) in Cambodia in 2011 to that in 2012?
Make the answer very short. 0.84. What is the ratio of the ATMs(per 100,000 adults) of Luxembourg in 2011 to that in 2012?
Ensure brevity in your answer.  1.05. What is the ratio of the ATMs(per 100,000 adults) of Paraguay in 2011 to that in 2012?
Your answer should be compact. 0.93. What is the ratio of the ATMs(per 100,000 adults) in Central Europe in 2011 to that in 2013?
Ensure brevity in your answer.  1.01. What is the ratio of the ATMs(per 100,000 adults) of Cambodia in 2011 to that in 2013?
Provide a succinct answer. 0.71. What is the ratio of the ATMs(per 100,000 adults) of Luxembourg in 2011 to that in 2013?
Keep it short and to the point. 1.08. What is the ratio of the ATMs(per 100,000 adults) in Paraguay in 2011 to that in 2013?
Ensure brevity in your answer.  0.81. What is the ratio of the ATMs(per 100,000 adults) in Central Europe in 2011 to that in 2014?
Your answer should be compact. 1.01. What is the ratio of the ATMs(per 100,000 adults) of Cambodia in 2011 to that in 2014?
Give a very brief answer. 0.55. What is the ratio of the ATMs(per 100,000 adults) in Paraguay in 2011 to that in 2014?
Offer a very short reply. 0.79. What is the ratio of the ATMs(per 100,000 adults) in Central Europe in 2012 to that in 2013?
Provide a succinct answer. 1.02. What is the ratio of the ATMs(per 100,000 adults) in Cambodia in 2012 to that in 2013?
Your answer should be compact. 0.84. What is the ratio of the ATMs(per 100,000 adults) of Paraguay in 2012 to that in 2013?
Keep it short and to the point. 0.87. What is the ratio of the ATMs(per 100,000 adults) in Central Europe in 2012 to that in 2014?
Your answer should be compact. 1.01. What is the ratio of the ATMs(per 100,000 adults) of Cambodia in 2012 to that in 2014?
Your answer should be very brief. 0.65. What is the ratio of the ATMs(per 100,000 adults) in Luxembourg in 2012 to that in 2014?
Offer a terse response. 0.95. What is the ratio of the ATMs(per 100,000 adults) of Paraguay in 2012 to that in 2014?
Your response must be concise. 0.85. What is the ratio of the ATMs(per 100,000 adults) in Central Europe in 2013 to that in 2014?
Offer a terse response. 1. What is the ratio of the ATMs(per 100,000 adults) in Cambodia in 2013 to that in 2014?
Offer a very short reply. 0.77. What is the ratio of the ATMs(per 100,000 adults) of Luxembourg in 2013 to that in 2014?
Provide a succinct answer. 0.93. What is the ratio of the ATMs(per 100,000 adults) of Paraguay in 2013 to that in 2014?
Ensure brevity in your answer.  0.98. What is the difference between the highest and the second highest ATMs(per 100,000 adults) of Central Europe?
Ensure brevity in your answer.  0.19. What is the difference between the highest and the second highest ATMs(per 100,000 adults) of Cambodia?
Ensure brevity in your answer.  2.41. What is the difference between the highest and the second highest ATMs(per 100,000 adults) in Luxembourg?
Ensure brevity in your answer.  0.76. What is the difference between the highest and the second highest ATMs(per 100,000 adults) of Paraguay?
Offer a terse response. 0.53. What is the difference between the highest and the lowest ATMs(per 100,000 adults) in Central Europe?
Make the answer very short. 6.83. What is the difference between the highest and the lowest ATMs(per 100,000 adults) in Cambodia?
Your response must be concise. 6.46. What is the difference between the highest and the lowest ATMs(per 100,000 adults) of Luxembourg?
Your response must be concise. 8.43. What is the difference between the highest and the lowest ATMs(per 100,000 adults) of Paraguay?
Offer a very short reply. 10.79. 